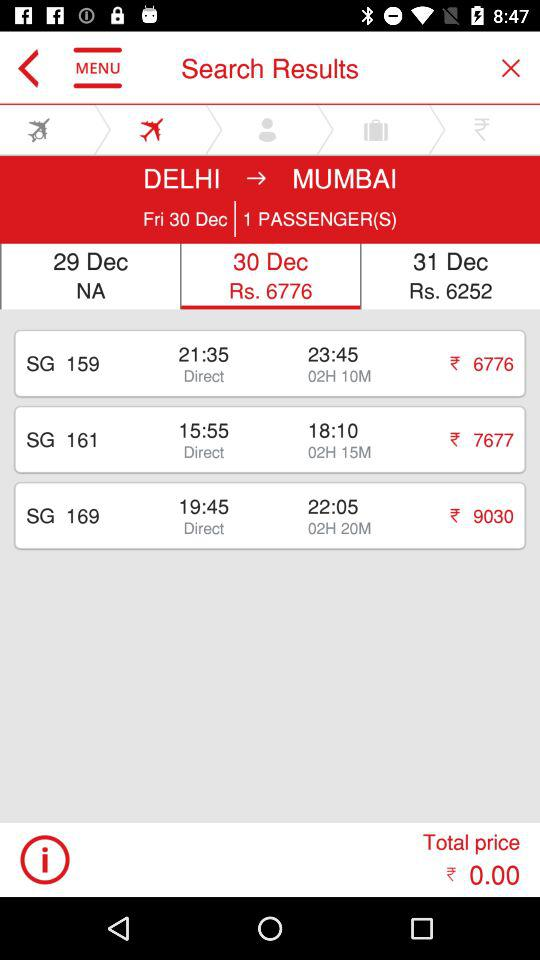How much more expensive is the 19:45 flight than the 21:35 flight?
Answer the question using a single word or phrase. 2254 